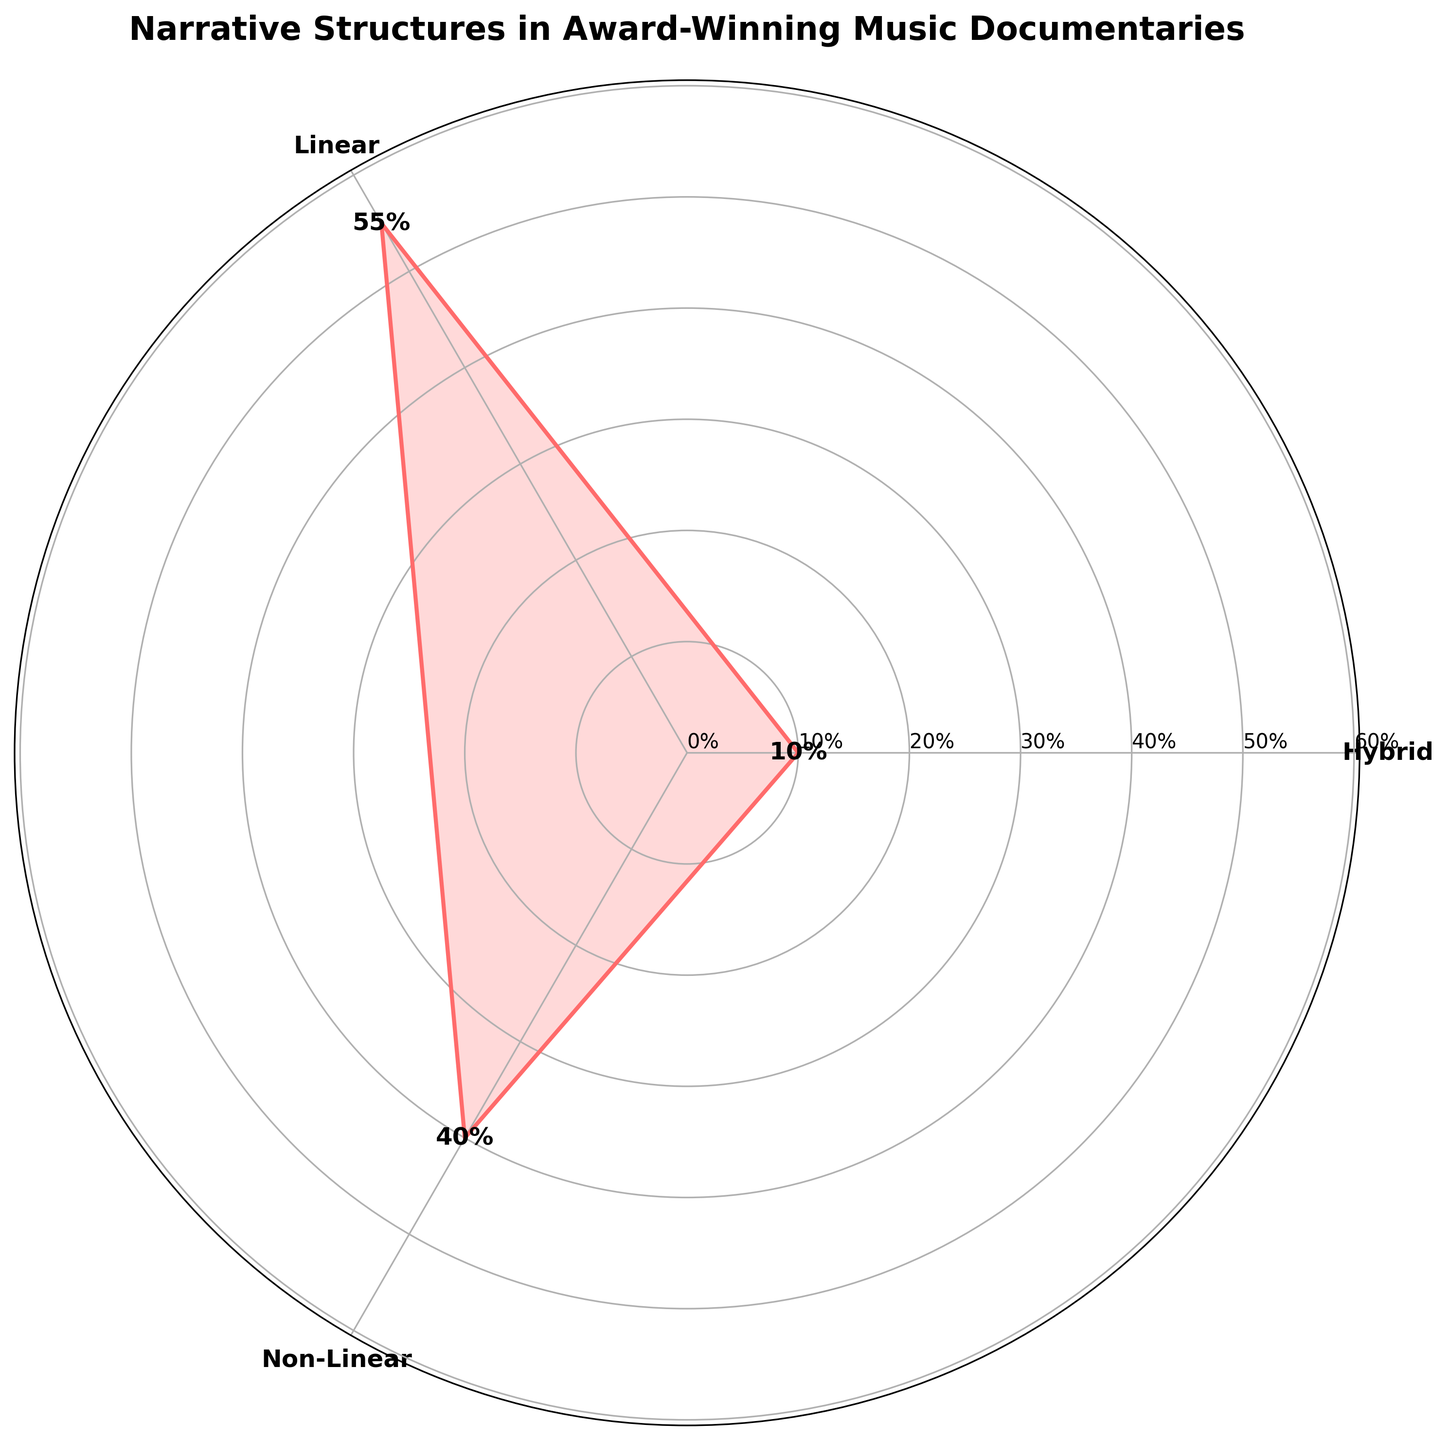What is the title of the figure? The title of the figure is displayed at the top and often summarizes the content of the chart.
Answer: Narrative Structures in Award-Winning Music Documentaries How many categories are represented in the chart? There are labels on the chart representing the different categories. You just need to count them.
Answer: 3 Which narrative structure has the highest percentage? By comparing the lengths of the different sections on the chart, the largest section's label corresponds to the highest percentage.
Answer: Linear What is the percentage of Hybrid narrative structures? The percentage can be found close to the label "Hybrid" on the chart.
Answer: 10% What is the combined percentage of Linear and Non-Linear structures? Add the percentages of the Linear and Non-Linear structures shown on the chart.
Answer: 95% How does the percentage of Non-Linear compare to that of Hybrid? Compare the percentages next to the labels of Non-Linear and Hybrid categories.
Answer: Non-Linear is higher Which two narrative structures are equal in percentage? By looking at the values on the chart, we find which categories have the same length sections representing their percentages.
Answer: Non-Linear (20%) and Non-Linear (20%) What narrative structure is the second most used in award-winning music documentaries? First identify each structure's percentage and then rank them in descending order. The second highest percentage corresponds to the second most used structure.
Answer: Non-Linear What is the most distinctive color used in the figure? The chart is primarily one color. The most distinctive color is the one used to fill the sections.
Answer: Red Is there any category with a percentage below 15%? By examining the percentages next to each category label, identify if any are below 15%.
Answer: Yes 